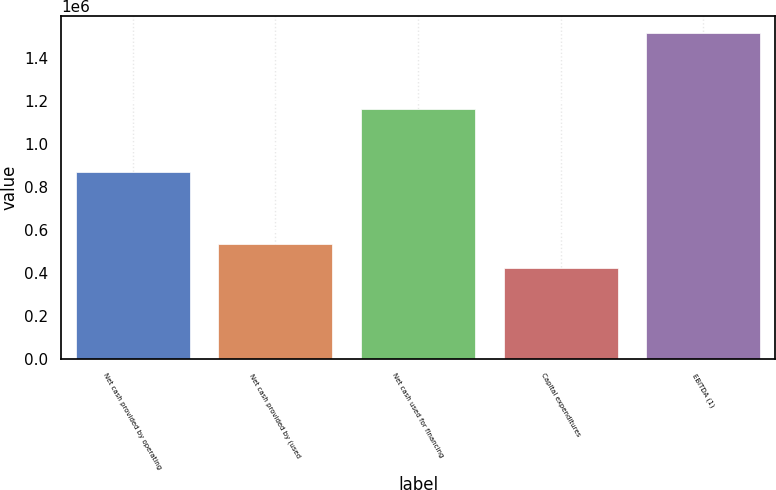<chart> <loc_0><loc_0><loc_500><loc_500><bar_chart><fcel>Net cash provided by operating<fcel>Net cash provided by (used<fcel>Net cash used for financing<fcel>Capital expenditures<fcel>EBITDA (1)<nl><fcel>869174<fcel>534161<fcel>1.16004e+06<fcel>425127<fcel>1.51547e+06<nl></chart> 